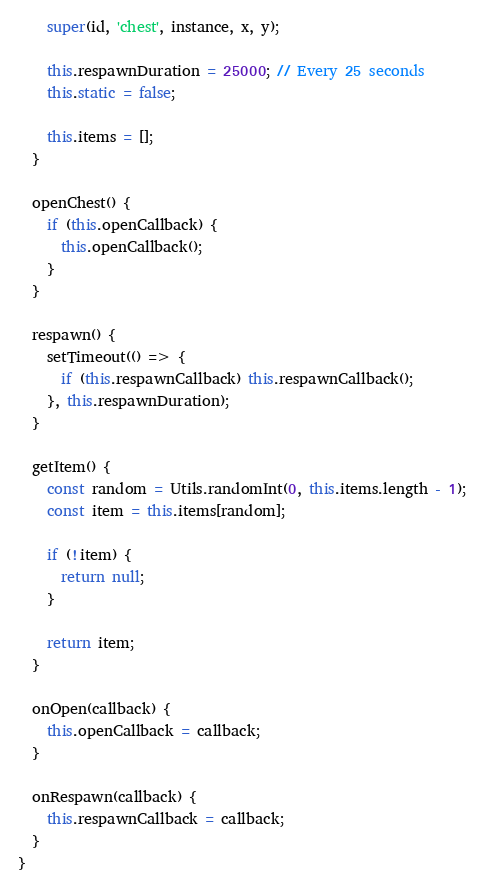Convert code to text. <code><loc_0><loc_0><loc_500><loc_500><_JavaScript_>    super(id, 'chest', instance, x, y);

    this.respawnDuration = 25000; // Every 25 seconds
    this.static = false;

    this.items = [];
  }

  openChest() {
    if (this.openCallback) {
      this.openCallback();
    }
  }

  respawn() {
    setTimeout(() => {
      if (this.respawnCallback) this.respawnCallback();
    }, this.respawnDuration);
  }

  getItem() {
    const random = Utils.randomInt(0, this.items.length - 1);
    const item = this.items[random];

    if (!item) {
      return null;
    }

    return item;
  }

  onOpen(callback) {
    this.openCallback = callback;
  }

  onRespawn(callback) {
    this.respawnCallback = callback;
  }
}
</code> 